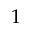Convert formula to latex. <formula><loc_0><loc_0><loc_500><loc_500>1</formula> 